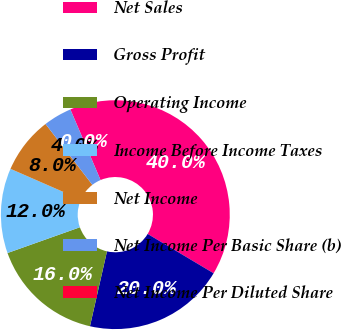<chart> <loc_0><loc_0><loc_500><loc_500><pie_chart><fcel>Net Sales<fcel>Gross Profit<fcel>Operating Income<fcel>Income Before Income Taxes<fcel>Net Income<fcel>Net Income Per Basic Share (b)<fcel>Net Income Per Diluted Share<nl><fcel>39.98%<fcel>20.0%<fcel>16.0%<fcel>12.0%<fcel>8.0%<fcel>4.01%<fcel>0.01%<nl></chart> 